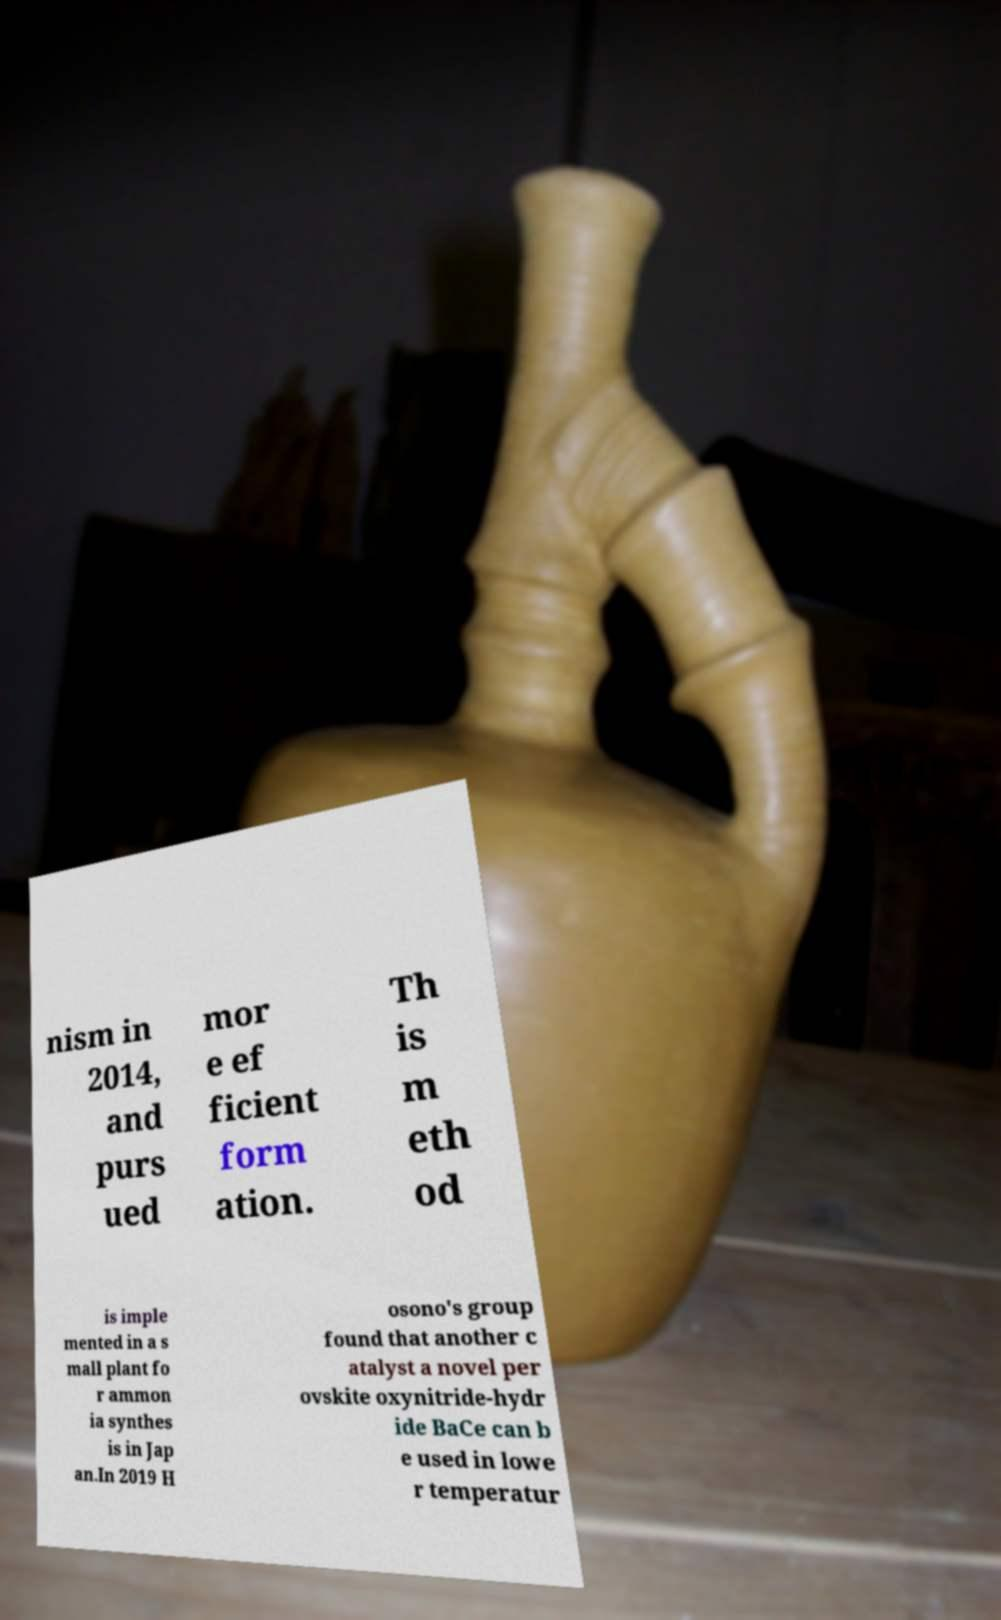Please read and relay the text visible in this image. What does it say? nism in 2014, and purs ued mor e ef ficient form ation. Th is m eth od is imple mented in a s mall plant fo r ammon ia synthes is in Jap an.In 2019 H osono's group found that another c atalyst a novel per ovskite oxynitride-hydr ide BaCe can b e used in lowe r temperatur 